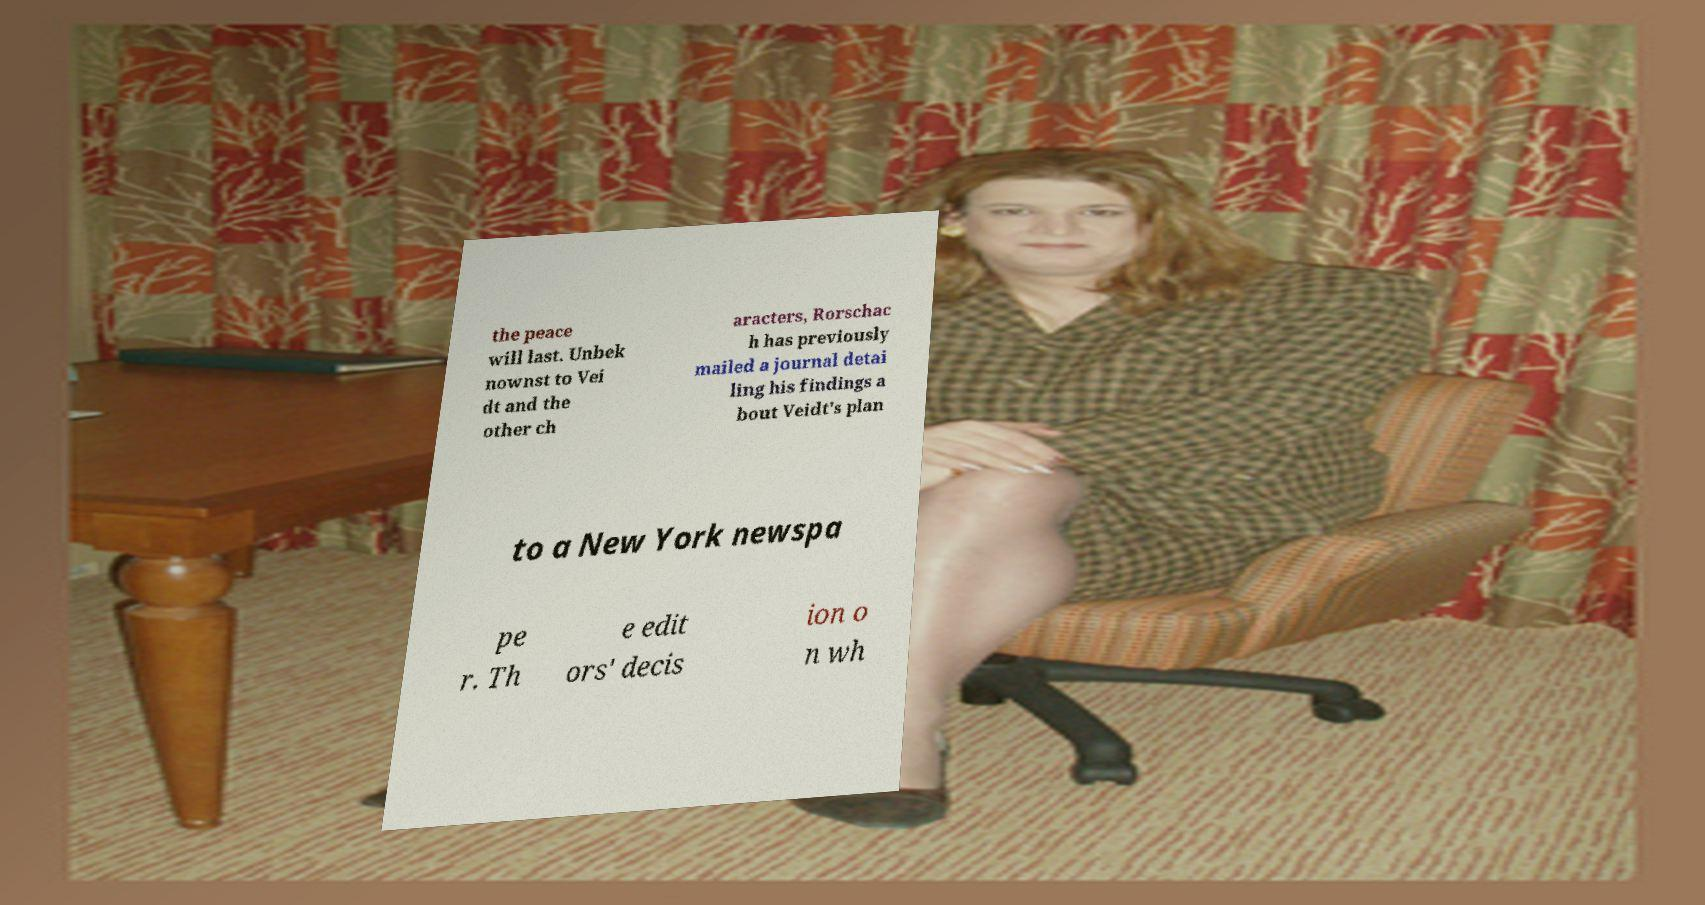Could you assist in decoding the text presented in this image and type it out clearly? the peace will last. Unbek nownst to Vei dt and the other ch aracters, Rorschac h has previously mailed a journal detai ling his findings a bout Veidt's plan to a New York newspa pe r. Th e edit ors' decis ion o n wh 